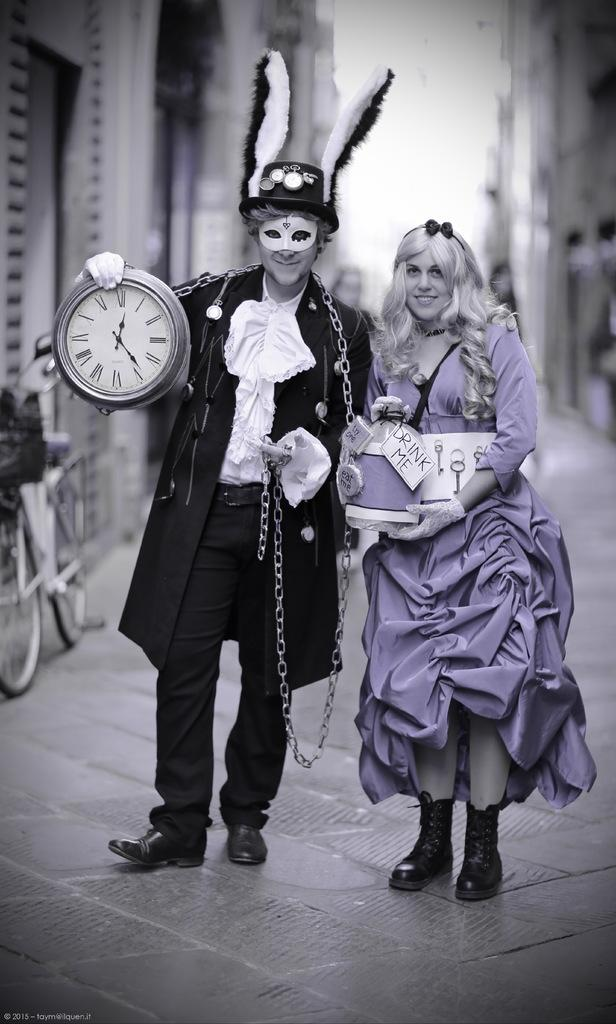<image>
Present a compact description of the photo's key features. Woman wearing a sign which says DRINK ME standing next to a man holdign a clock. 